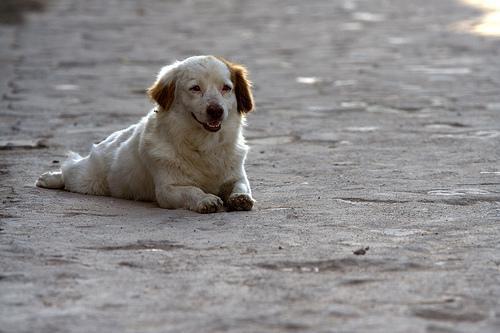How many dogs are there?
Give a very brief answer. 1. 